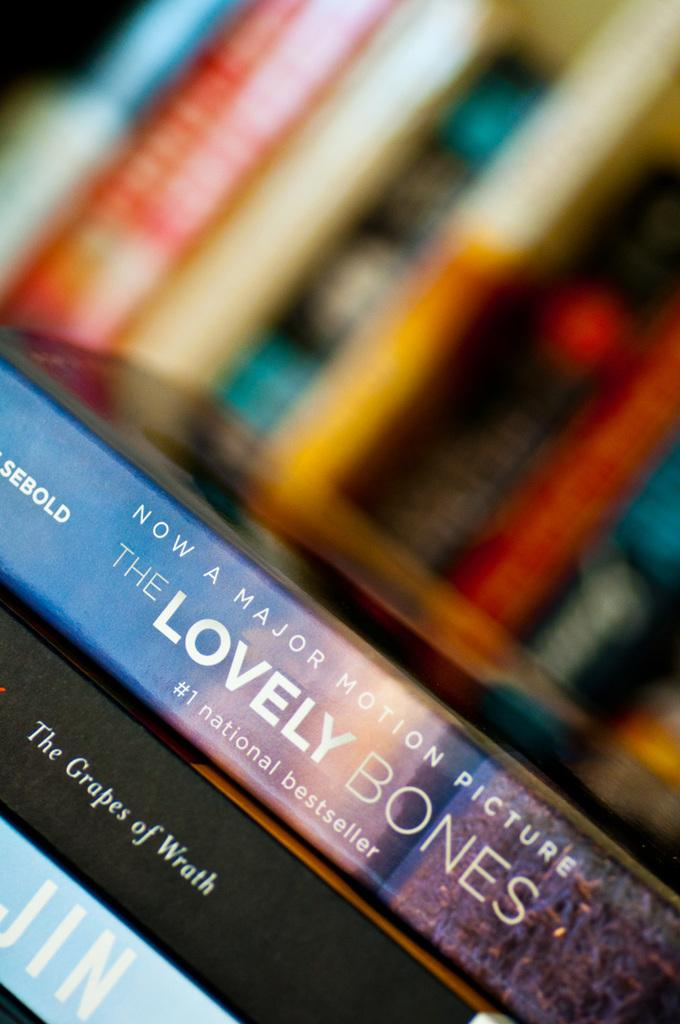<image>
Relay a brief, clear account of the picture shown. Movie spines are lined up, the most visible The Grapes of Wrath and The Lovely Bones. 